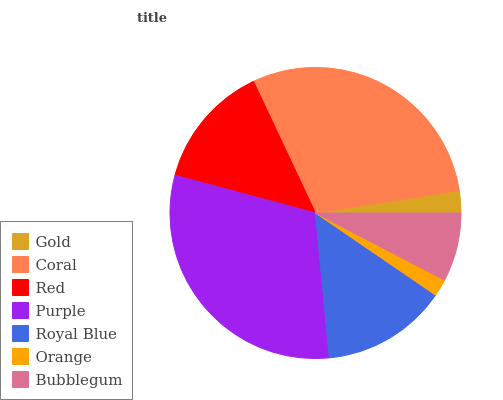Is Orange the minimum?
Answer yes or no. Yes. Is Purple the maximum?
Answer yes or no. Yes. Is Coral the minimum?
Answer yes or no. No. Is Coral the maximum?
Answer yes or no. No. Is Coral greater than Gold?
Answer yes or no. Yes. Is Gold less than Coral?
Answer yes or no. Yes. Is Gold greater than Coral?
Answer yes or no. No. Is Coral less than Gold?
Answer yes or no. No. Is Red the high median?
Answer yes or no. Yes. Is Red the low median?
Answer yes or no. Yes. Is Orange the high median?
Answer yes or no. No. Is Purple the low median?
Answer yes or no. No. 